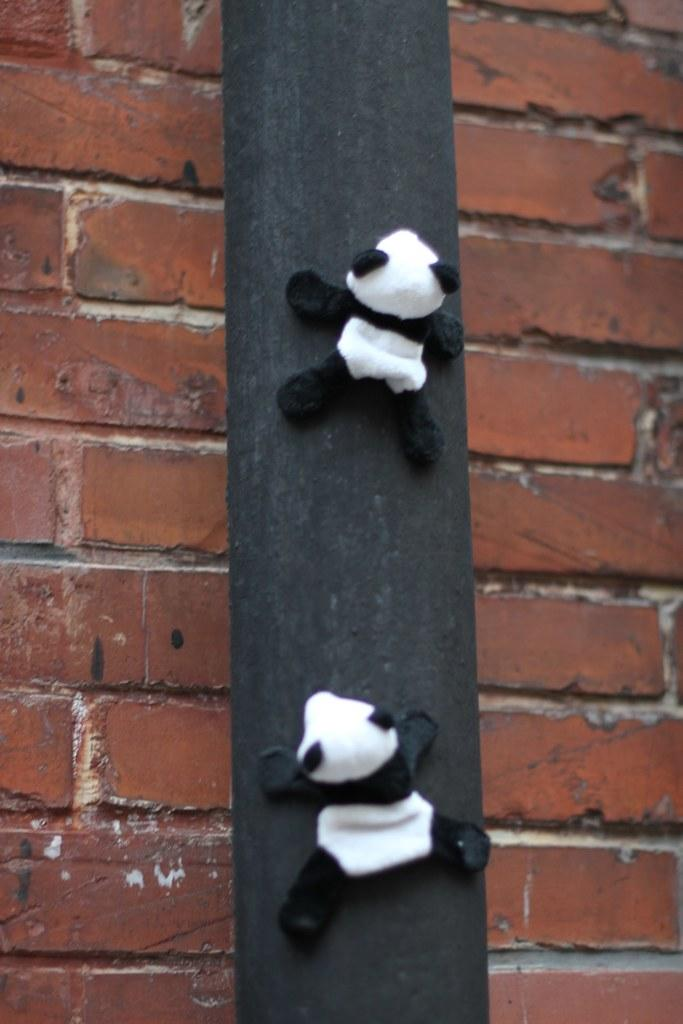What type of toys are in the image? There are panda toys in the image. How are the panda toys arranged or positioned? The panda toys are on a wooden pole. What can be seen in the background of the image? There is a brick wall in the background of the image. What type of agreement is being discussed by the pandas in the image? There are no pandas or discussions present in the image; it features panda toys on a wooden pole with a brick wall in the background. 